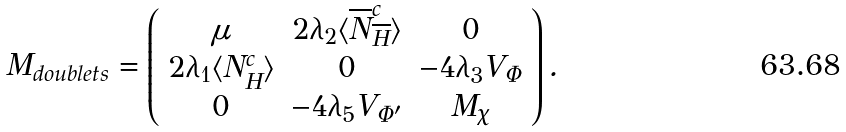Convert formula to latex. <formula><loc_0><loc_0><loc_500><loc_500>M _ { d o u b l e t s } = \left ( \begin{array} { c c c } \mu & 2 \lambda _ { 2 } \langle \overline { N } _ { \overline { H } } ^ { c } \rangle & 0 \\ 2 \lambda _ { 1 } \langle N _ { H } ^ { c } \rangle & 0 & - 4 \lambda _ { 3 } V _ { \Phi } \\ 0 & - 4 \lambda _ { 5 } V _ { \Phi ^ { \prime } } & M _ { \chi } \end{array} \right ) . \,</formula> 